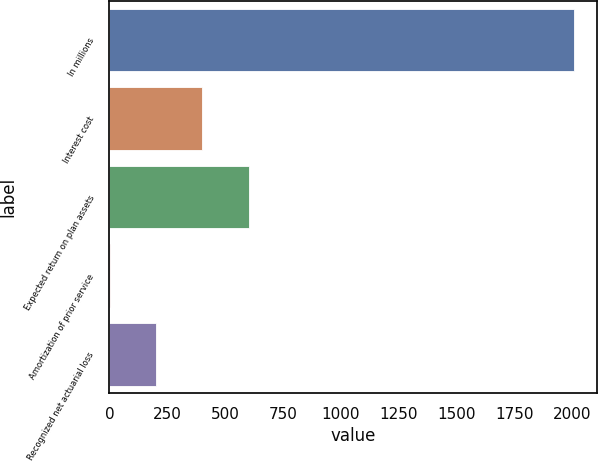<chart> <loc_0><loc_0><loc_500><loc_500><bar_chart><fcel>In millions<fcel>Interest cost<fcel>Expected return on plan assets<fcel>Amortization of prior service<fcel>Recognized net actuarial loss<nl><fcel>2007<fcel>402.2<fcel>602.8<fcel>1<fcel>201.6<nl></chart> 